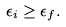<formula> <loc_0><loc_0><loc_500><loc_500>\epsilon _ { i } \geq \epsilon _ { f } .</formula> 